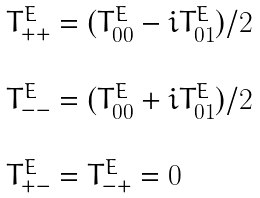<formula> <loc_0><loc_0><loc_500><loc_500>\begin{array} { l l } T _ { + + } ^ { E } = ( T _ { 0 0 } ^ { E } - i T _ { 0 1 } ^ { E } ) / 2 \\ \\ T _ { - - } ^ { E } = ( T _ { 0 0 } ^ { E } + i T _ { 0 1 } ^ { E } ) / 2 \\ \\ T _ { + - } ^ { E } = T _ { - + } ^ { E } = 0 \end{array}</formula> 